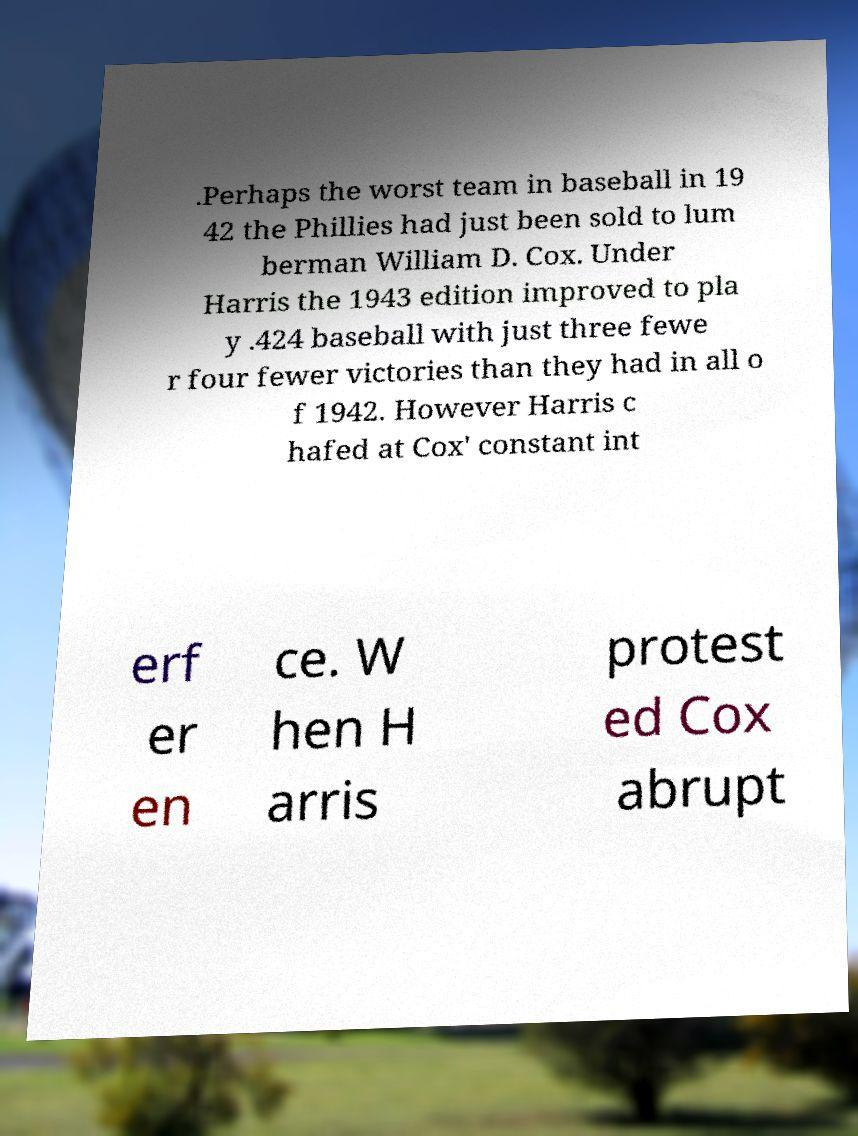Could you extract and type out the text from this image? .Perhaps the worst team in baseball in 19 42 the Phillies had just been sold to lum berman William D. Cox. Under Harris the 1943 edition improved to pla y .424 baseball with just three fewe r four fewer victories than they had in all o f 1942. However Harris c hafed at Cox' constant int erf er en ce. W hen H arris protest ed Cox abrupt 